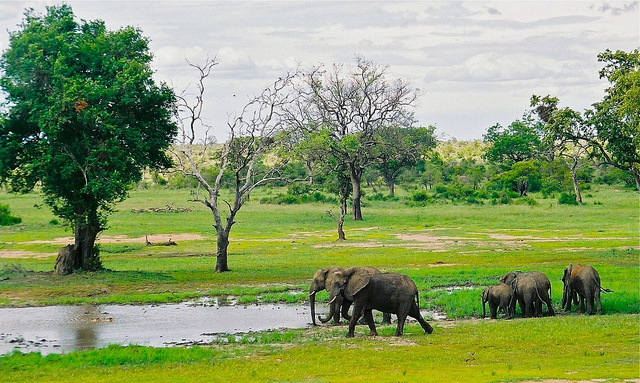Describe the objects in this image and their specific colors. I can see elephant in lightgray, black, gray, and darkgreen tones, elephant in lightgray, black, gray, and olive tones, elephant in lightgray, black, gray, olive, and darkgreen tones, elephant in lightgray, black, gray, and darkgreen tones, and elephant in lightgray, black, gray, and tan tones in this image. 